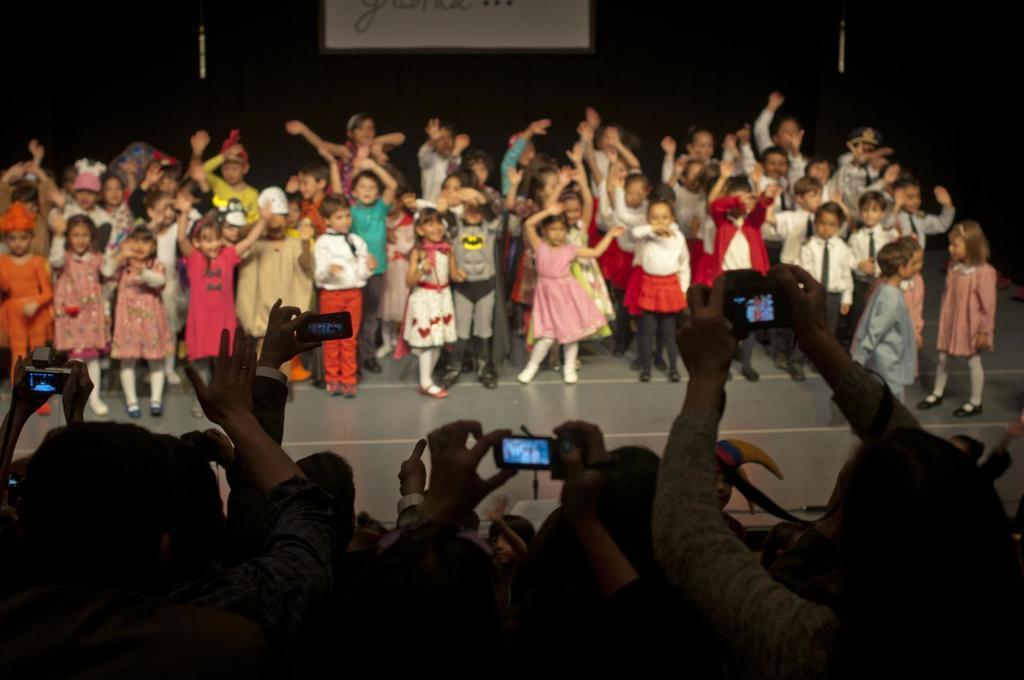Describe this image in one or two sentences. In this image we can see a group of children standing on the stage. We can also see a board with some text on it. In the foreground we can see a group of people. In that some are holding the mobile phones. 